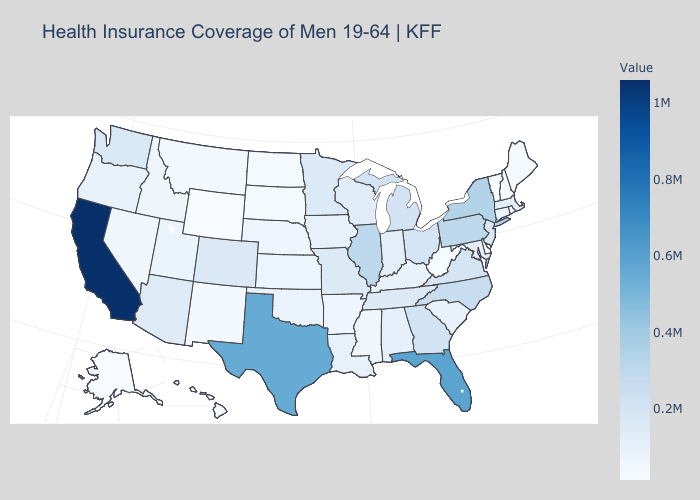Which states have the highest value in the USA?
Keep it brief. California. Does Utah have the lowest value in the USA?
Quick response, please. No. Does Georgia have the lowest value in the USA?
Quick response, please. No. Does South Carolina have the lowest value in the South?
Keep it brief. No. Does Montana have the lowest value in the USA?
Answer briefly. No. Which states have the lowest value in the Northeast?
Short answer required. Vermont. Is the legend a continuous bar?
Keep it brief. Yes. Does Delaware have a lower value than Michigan?
Short answer required. Yes. 